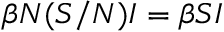Convert formula to latex. <formula><loc_0><loc_0><loc_500><loc_500>\beta N ( S / N ) I = \beta S I</formula> 